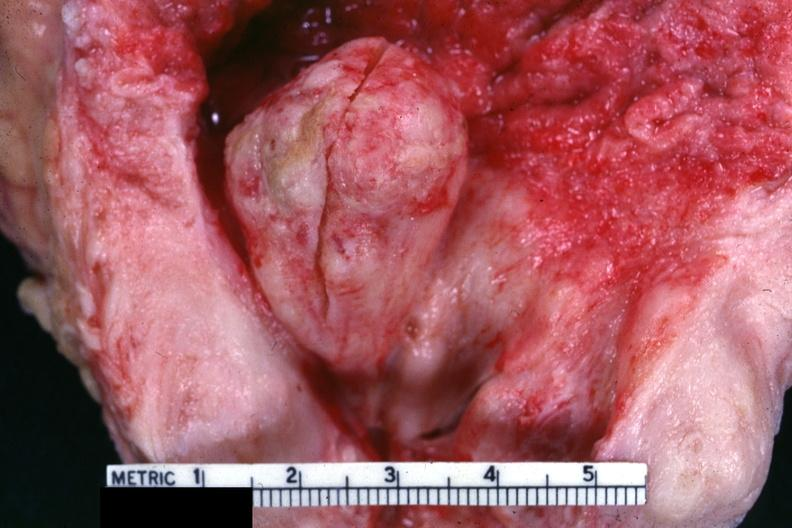s nodule present?
Answer the question using a single word or phrase. No 